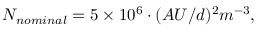Convert formula to latex. <formula><loc_0><loc_0><loc_500><loc_500>\begin{array} { r } { { N _ { n o \min a l } = 5 \times 1 0 ^ { 6 } \cdot ( A U / d ) ^ { 2 } m ^ { - 3 } , } } \end{array}</formula> 